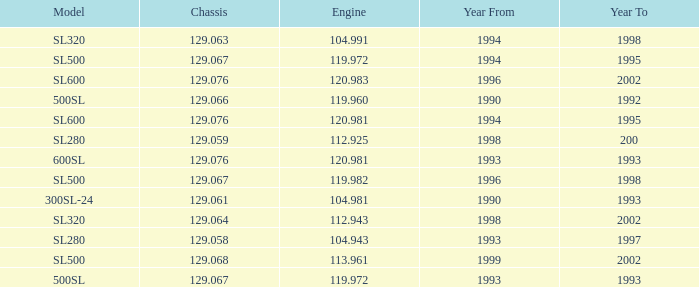How many engines have a Model of sl600, and a Year From of 1994, and a Year To smaller than 1995? 0.0. 